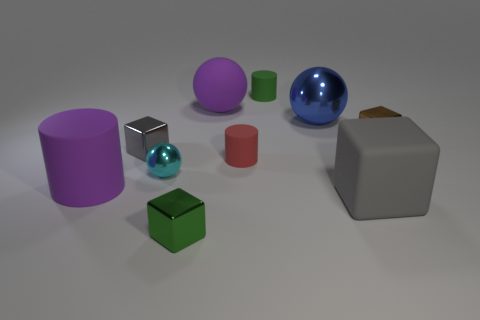Subtract all big purple cylinders. How many cylinders are left? 2 Subtract all green cubes. How many cubes are left? 3 Subtract all yellow cylinders. How many gray blocks are left? 2 Subtract all blocks. How many objects are left? 6 Subtract 2 cylinders. How many cylinders are left? 1 Subtract all large purple metal cubes. Subtract all small green cylinders. How many objects are left? 9 Add 5 tiny green rubber cylinders. How many tiny green rubber cylinders are left? 6 Add 1 large yellow metal cubes. How many large yellow metal cubes exist? 1 Subtract 1 gray cubes. How many objects are left? 9 Subtract all cyan cylinders. Subtract all yellow cubes. How many cylinders are left? 3 